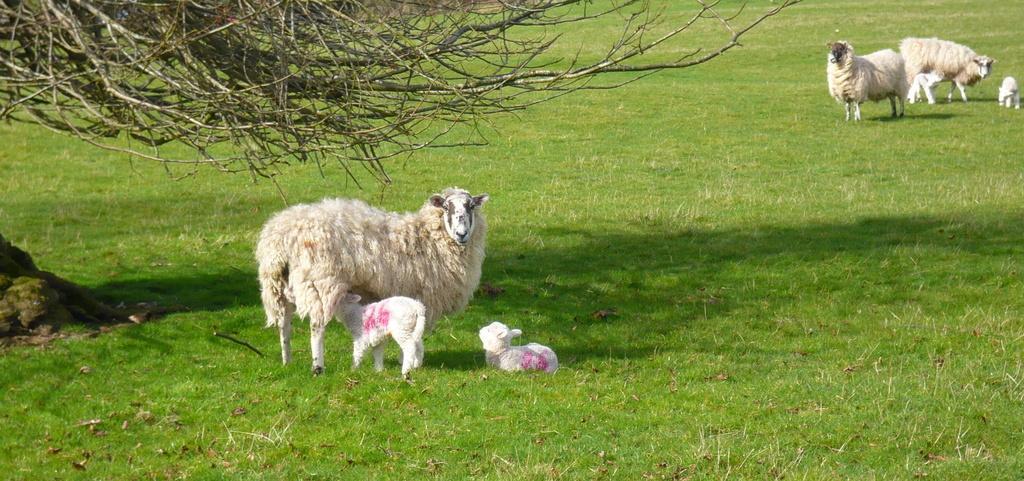In one or two sentences, can you explain what this image depicts? This is an outside view. Here I can see the grass on the ground. In this image there are few animals. At the top of the image I can see a part of a tree. 